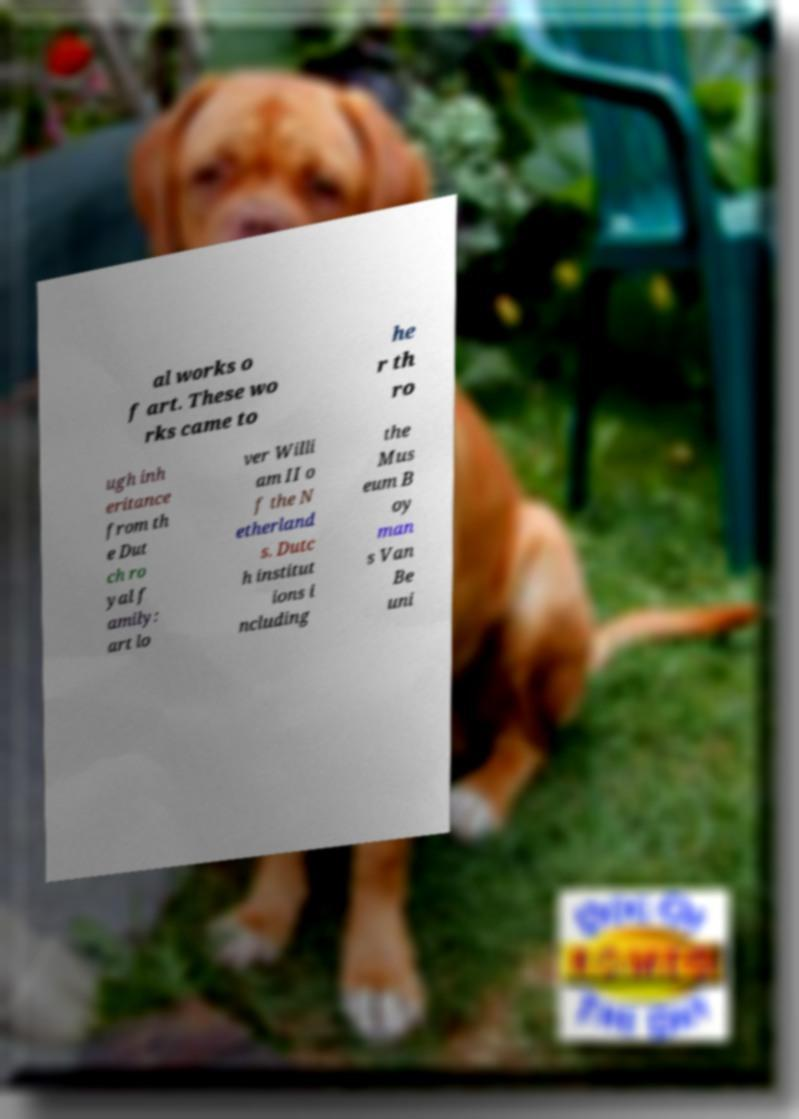Could you extract and type out the text from this image? al works o f art. These wo rks came to he r th ro ugh inh eritance from th e Dut ch ro yal f amily: art lo ver Willi am II o f the N etherland s. Dutc h institut ions i ncluding the Mus eum B oy man s Van Be uni 